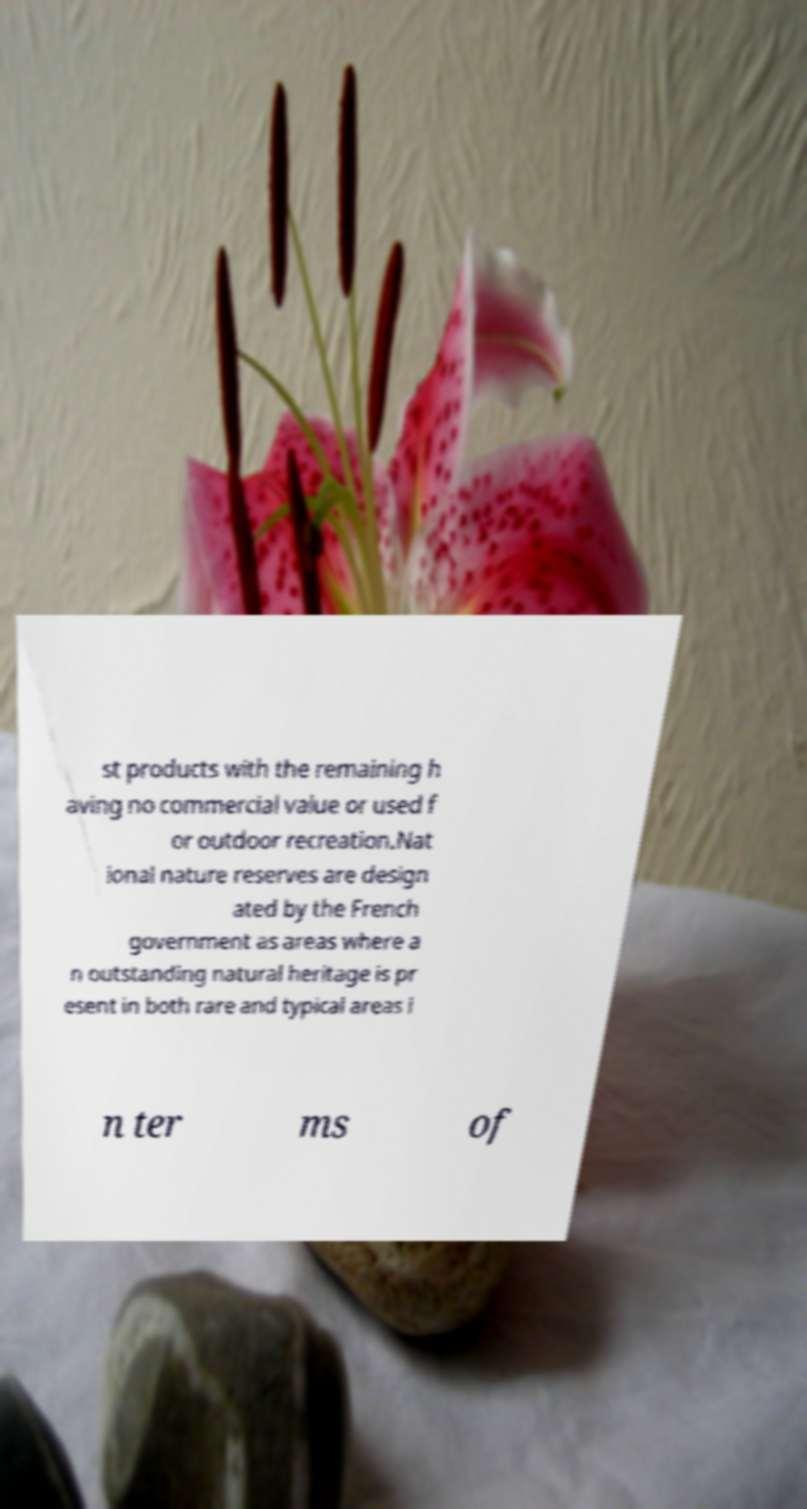There's text embedded in this image that I need extracted. Can you transcribe it verbatim? st products with the remaining h aving no commercial value or used f or outdoor recreation.Nat ional nature reserves are design ated by the French government as areas where a n outstanding natural heritage is pr esent in both rare and typical areas i n ter ms of 